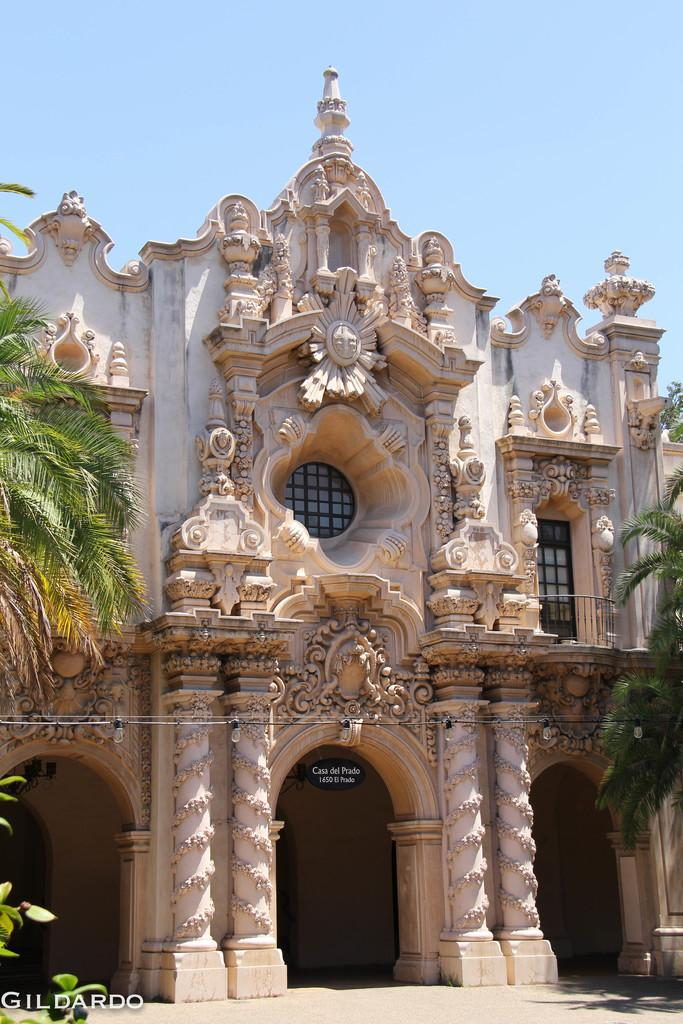What type of structure is visible in the image? There is a building in the image. What can be seen on both sides of the building? There are trees on either side of the image. What other types of vegetation are present in the image? There are plants in the image. What is visible at the top of the image? The sky is visible at the top of the image. Where was the image taken? The image was taken in Balboa Park. How many watches can be seen hanging from the trees in the image? There are no watches present in the image; it features a building, trees, plants, and the sky. What type of twig is used as a decoration on the building in the image? There is no twig used as a decoration on the building in the image. 